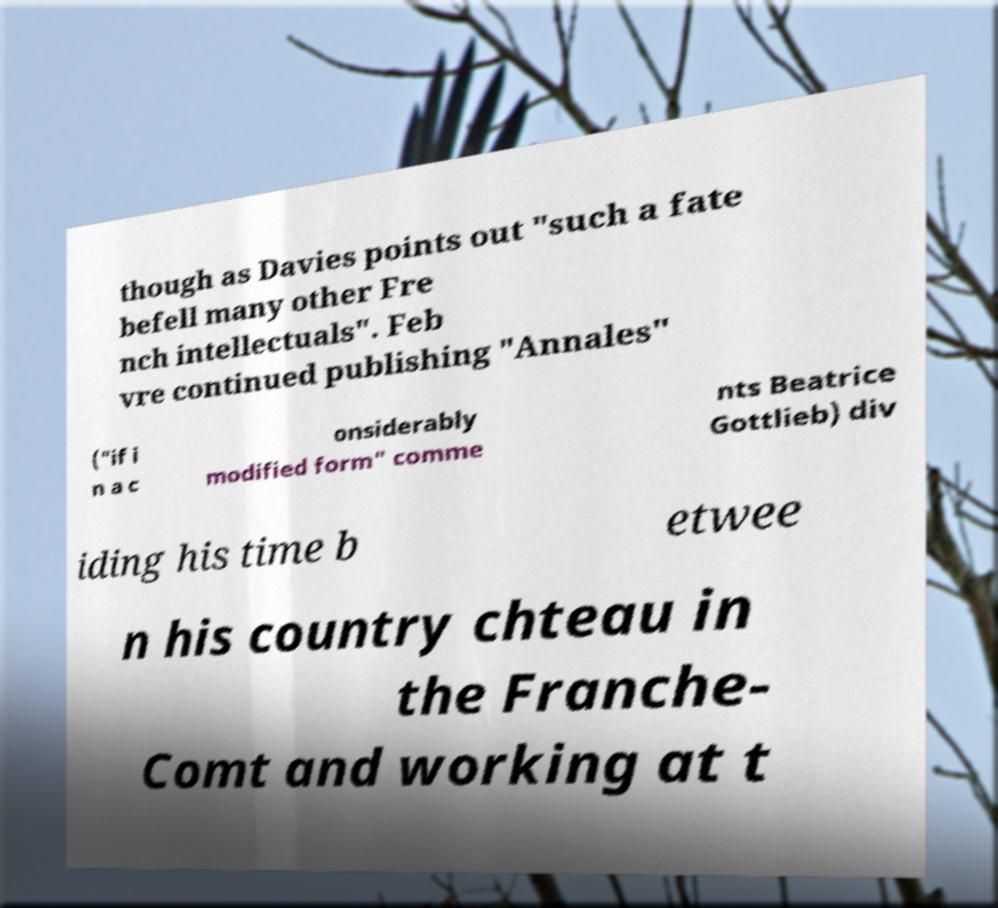Could you assist in decoding the text presented in this image and type it out clearly? though as Davies points out "such a fate befell many other Fre nch intellectuals". Feb vre continued publishing "Annales" ("if i n a c onsiderably modified form" comme nts Beatrice Gottlieb) div iding his time b etwee n his country chteau in the Franche- Comt and working at t 